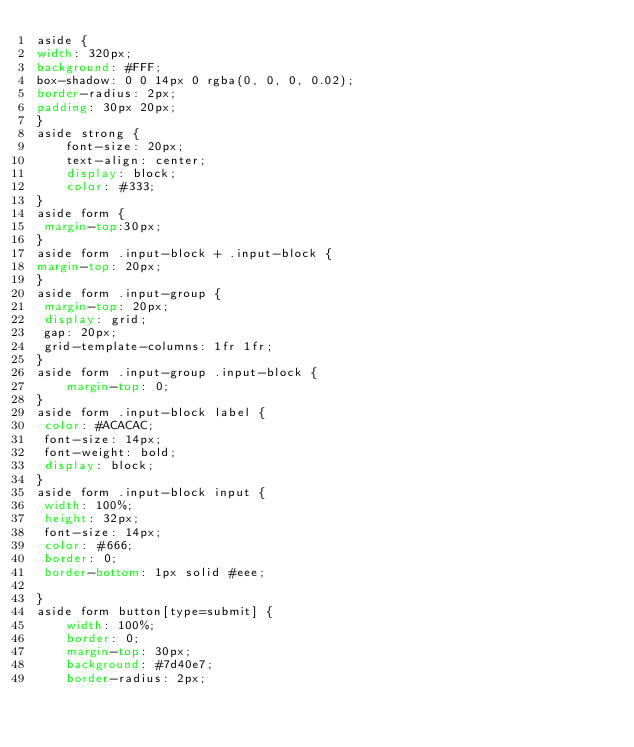Convert code to text. <code><loc_0><loc_0><loc_500><loc_500><_CSS_>aside {
width: 320px;
background: #FFF;
box-shadow: 0 0 14px 0 rgba(0, 0, 0, 0.02);
border-radius: 2px;
padding: 30px 20px;
}
aside strong {
    font-size: 20px;
    text-align: center;
    display: block;
    color: #333;
}
aside form {
 margin-top:30px;
}
aside form .input-block + .input-block {
margin-top: 20px;
}
aside form .input-group {
 margin-top: 20px;
 display: grid;
 gap: 20px;
 grid-template-columns: 1fr 1fr;
}
aside form .input-group .input-block {
    margin-top: 0;
}
aside form .input-block label {
 color: #ACACAC;
 font-size: 14px;
 font-weight: bold;
 display: block;
}
aside form .input-block input {
 width: 100%;
 height: 32px;
 font-size: 14px;
 color: #666;
 border: 0;
 border-bottom: 1px solid #eee;
 
}
aside form button[type=submit] {
    width: 100%;
    border: 0;
    margin-top: 30px;
    background: #7d40e7;
    border-radius: 2px;</code> 